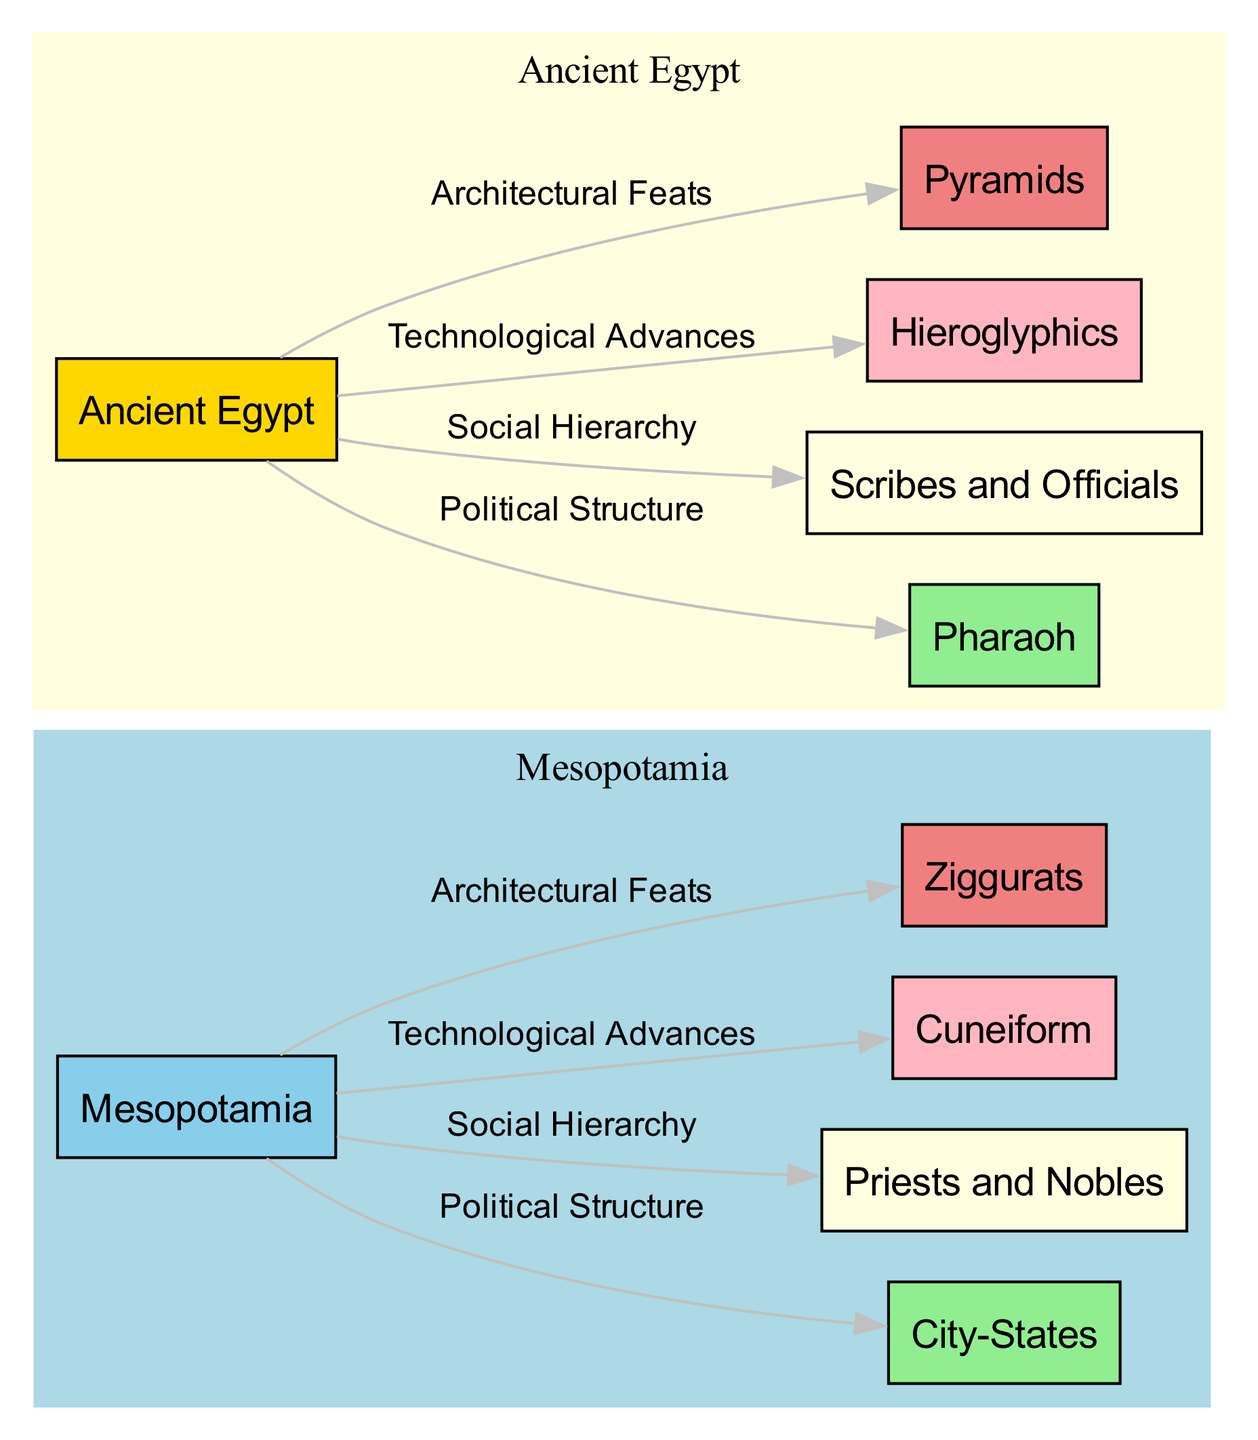What type of political structure does Mesopotamia have? The node labeled "City-States" comes from the Mesopotamia node, indicating that Mesopotamia's political structure is composed of city-states.
Answer: City-States Who is at the top of the social hierarchy in Ancient Egypt? The node "Pharaoh" is connected to the Ancient Egypt node, showing that it represents the highest position in the social hierarchy of Ancient Egypt.
Answer: Pharaoh What technological advancement is associated with Mesopotamia? "Cuneiform" is the node that is connected to the Mesopotamia node, representing a key technological advancement in that civilization.
Answer: Cuneiform What is an architectural feat associated with Ancient Egypt? The node "Pyramids" is linked from the Ancient Egypt node, indicating that Pyramids are a significant architectural achievement in Ancient Egypt.
Answer: Pyramids How many social hierarchy levels are identified for Mesopotamia? There are two nodes under Mesopotamia regarding social hierarchy: "Priests and Nobles" and "Scribes and Officials", which means there are two levels identified.
Answer: 2 Which civilization features both ziggurats and cuneiform? The Mesopotamia node connects to both "Ziggurats" and "Cuneiform" nodes, indicating that both architectural and technological features belong to Mesopotamia.
Answer: Mesopotamia What is the relationship between the Pharaoh and the social hierarchy of Ancient Egypt? The edge from the Ancient Egypt node to the "Pharaoh" node indicates that the Pharaoh is a key part of the social hierarchy in Ancient Egypt, depicting authority and governance.
Answer: Authority Which civilization developed hieroglyphics? The "Hieroglyphics" node is connected to the Ancient Egypt node, signifying that hieroglyphics are a significant technological development of Ancient Egypt.
Answer: Ancient Egypt What color is used to represent Mesopotamia in the diagram? Mesopotamia is represented in light blue, as seen in the color specified in the subgraph attributes for Mesopotamia.
Answer: Light blue 